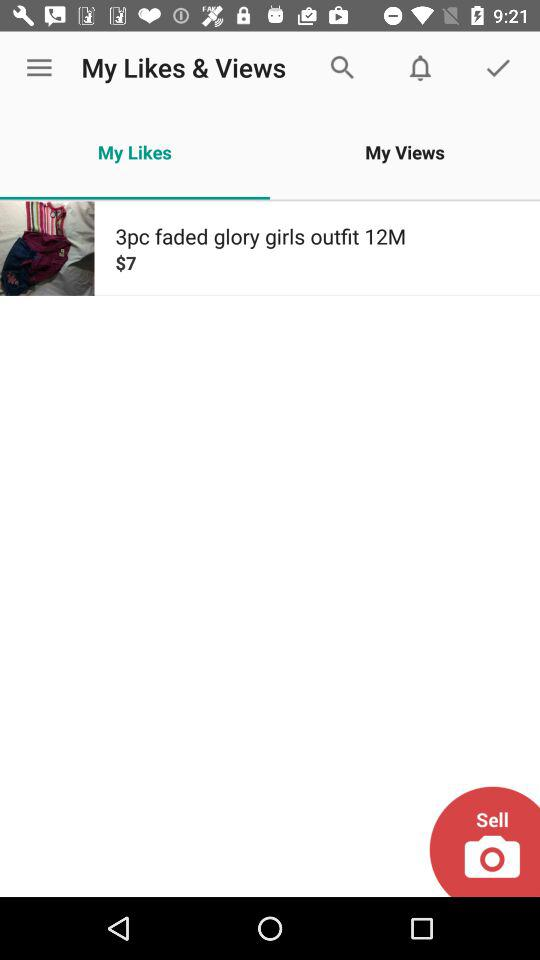What's the total number of pieces in the outfit? The total number of pieces in the outfit is 3. 